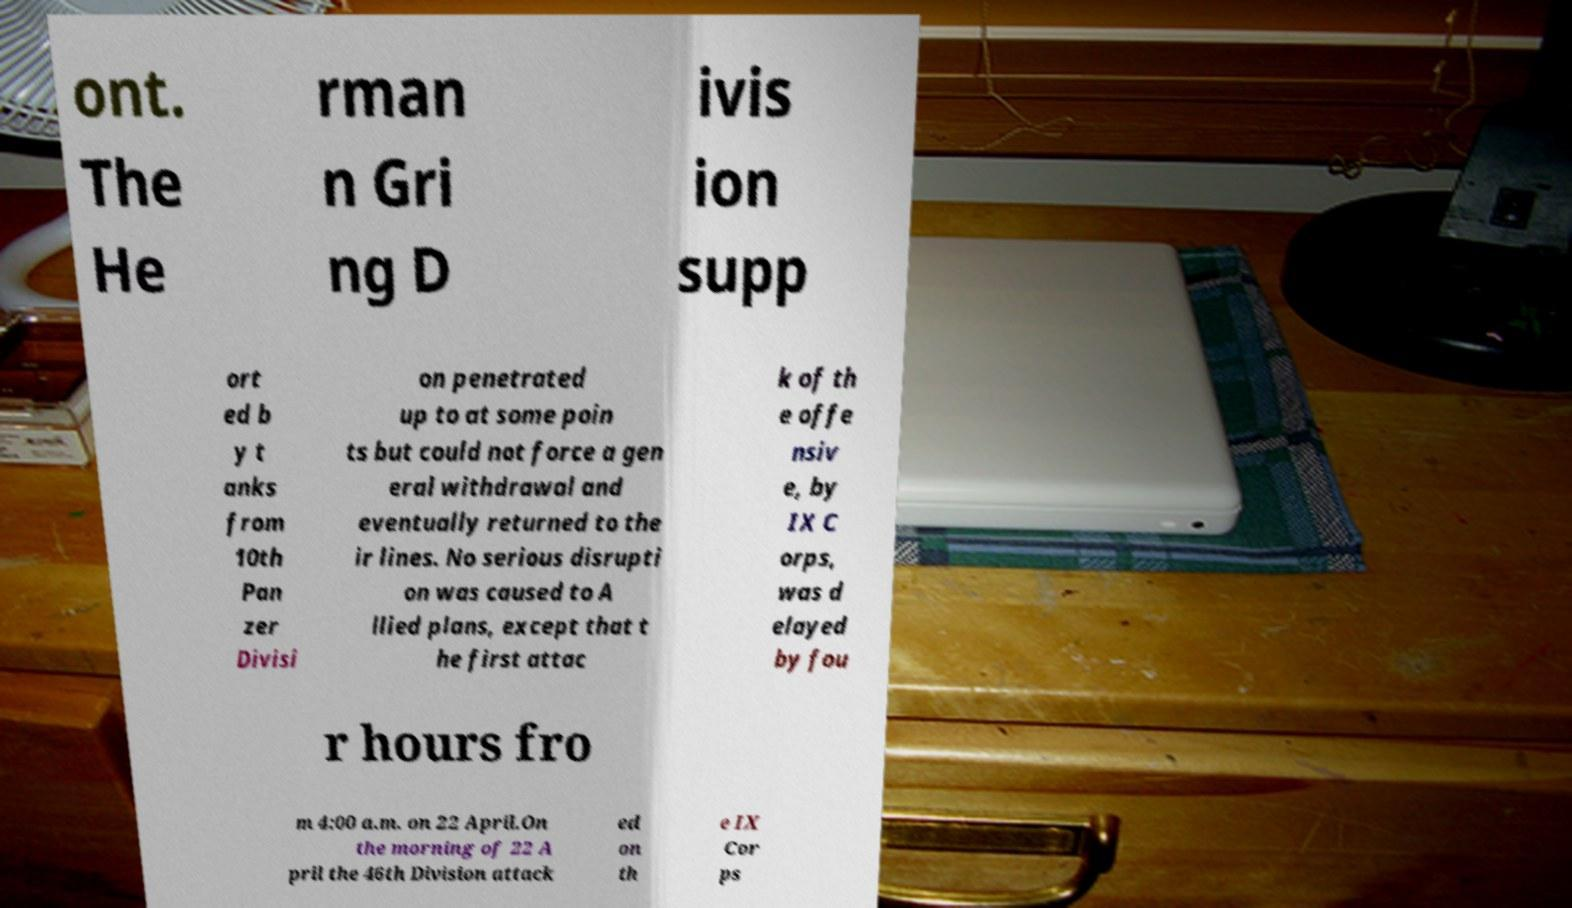Please read and relay the text visible in this image. What does it say? ont. The He rman n Gri ng D ivis ion supp ort ed b y t anks from 10th Pan zer Divisi on penetrated up to at some poin ts but could not force a gen eral withdrawal and eventually returned to the ir lines. No serious disrupti on was caused to A llied plans, except that t he first attac k of th e offe nsiv e, by IX C orps, was d elayed by fou r hours fro m 4:00 a.m. on 22 April.On the morning of 22 A pril the 46th Division attack ed on th e IX Cor ps 